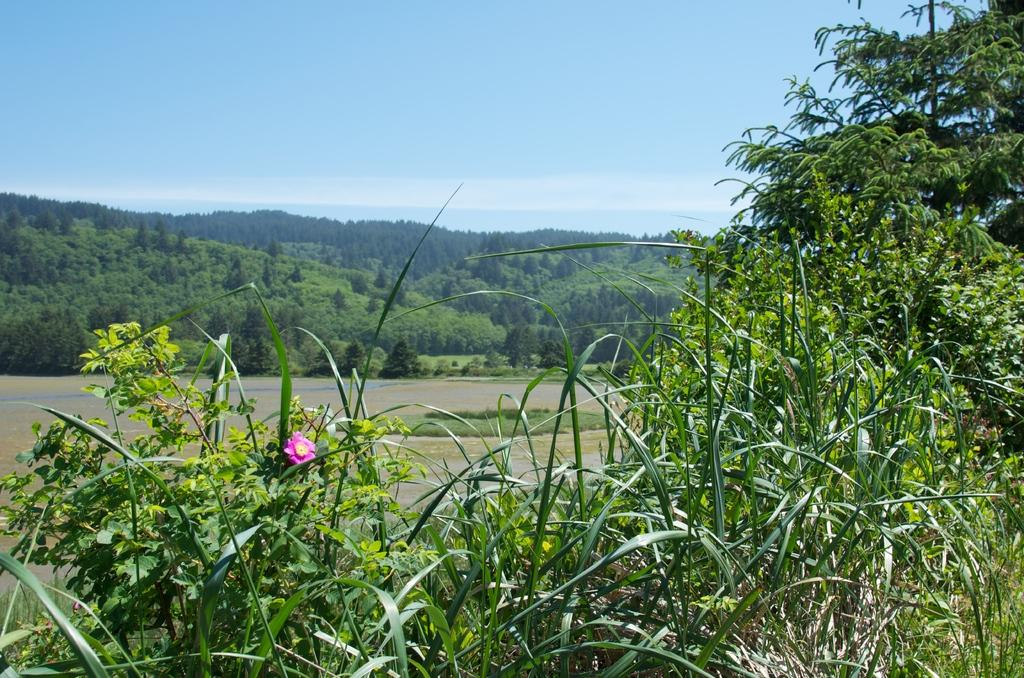What type of flower can be seen on the plant in the image? There is a pink flower on a plant in the image. What natural feature is visible in the background of the image? There is a river visible in the background of the image. What type of geographical feature can be seen in the background of the image? There are mountains in the background of the image. What type of vegetation is present in the background of the image? There are many trees in the background of the image. What part of the natural environment is visible in the top part of the image? The sky is visible in the top part of the image. What can be seen in the sky in the image? Clouds are present in the sky. What type of ornament is hanging from the tree in the image? There is no ornament hanging from the tree in the image; it only shows a pink flower on a plant, a river, mountains, trees, sky, and clouds. 